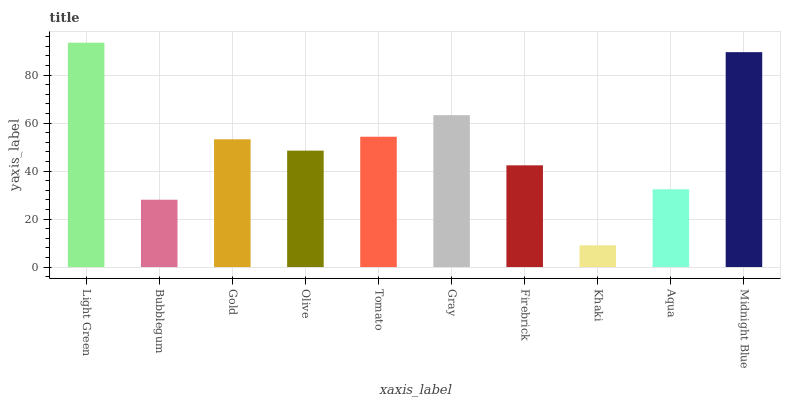Is Khaki the minimum?
Answer yes or no. Yes. Is Light Green the maximum?
Answer yes or no. Yes. Is Bubblegum the minimum?
Answer yes or no. No. Is Bubblegum the maximum?
Answer yes or no. No. Is Light Green greater than Bubblegum?
Answer yes or no. Yes. Is Bubblegum less than Light Green?
Answer yes or no. Yes. Is Bubblegum greater than Light Green?
Answer yes or no. No. Is Light Green less than Bubblegum?
Answer yes or no. No. Is Gold the high median?
Answer yes or no. Yes. Is Olive the low median?
Answer yes or no. Yes. Is Firebrick the high median?
Answer yes or no. No. Is Tomato the low median?
Answer yes or no. No. 